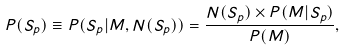<formula> <loc_0><loc_0><loc_500><loc_500>P ( S _ { p } ) \equiv P ( S _ { p } | M , N ( S _ { p } ) ) = \frac { N ( S _ { p } ) \times P ( M | S _ { p } ) } { P ( M ) } ,</formula> 